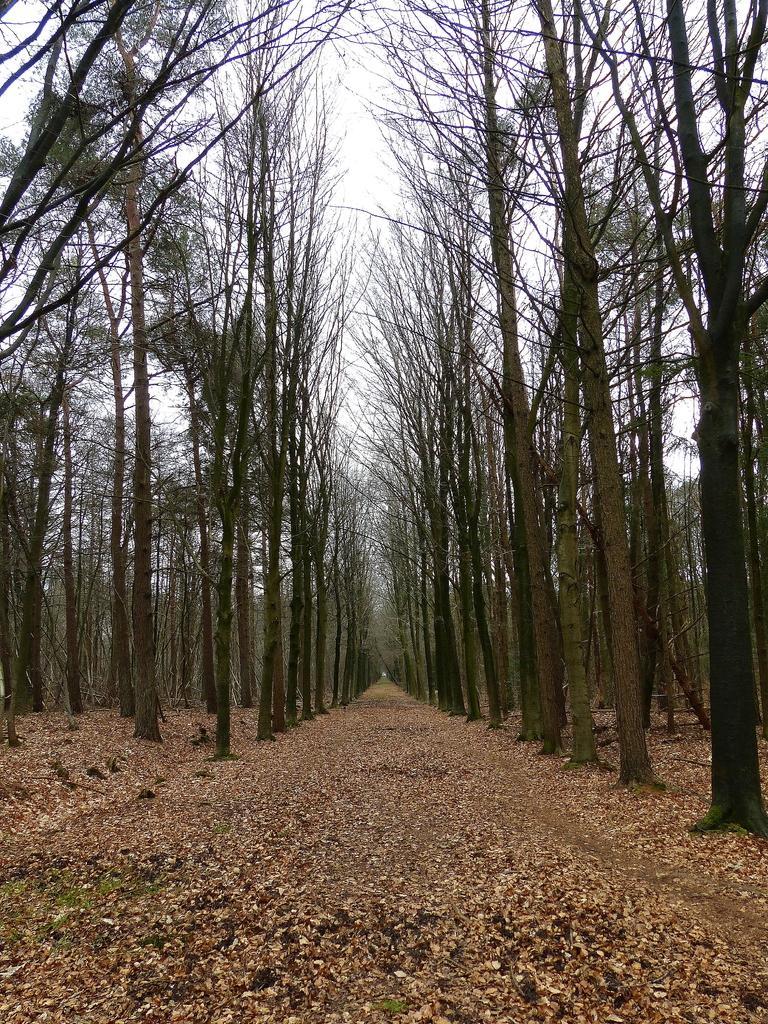In one or two sentences, can you explain what this image depicts? In this image I can see the ground, number of leaves on the ground and few trees. In the background I can see the sky. 